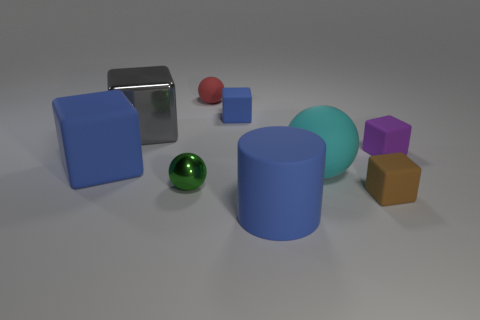Subtract all red spheres. How many spheres are left? 2 Add 1 blue cubes. How many objects exist? 10 Subtract all gray cubes. How many cubes are left? 4 Subtract all blocks. How many objects are left? 4 Subtract 1 cylinders. How many cylinders are left? 0 Subtract all brown spheres. Subtract all blue blocks. How many spheres are left? 3 Subtract all brown cylinders. How many gray cubes are left? 1 Subtract all small brown rubber objects. Subtract all brown blocks. How many objects are left? 7 Add 1 blue matte cylinders. How many blue matte cylinders are left? 2 Add 9 small metallic balls. How many small metallic balls exist? 10 